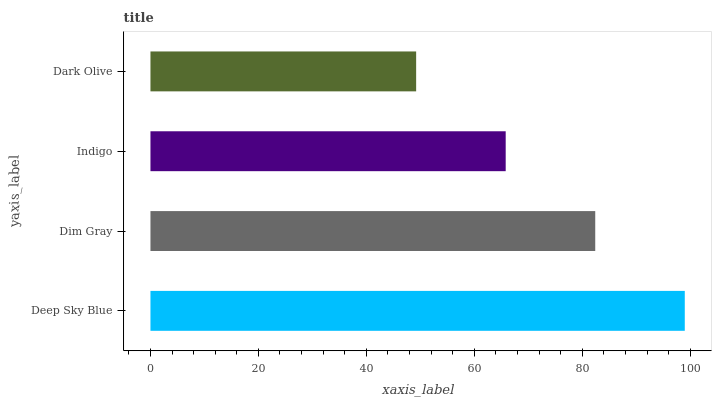Is Dark Olive the minimum?
Answer yes or no. Yes. Is Deep Sky Blue the maximum?
Answer yes or no. Yes. Is Dim Gray the minimum?
Answer yes or no. No. Is Dim Gray the maximum?
Answer yes or no. No. Is Deep Sky Blue greater than Dim Gray?
Answer yes or no. Yes. Is Dim Gray less than Deep Sky Blue?
Answer yes or no. Yes. Is Dim Gray greater than Deep Sky Blue?
Answer yes or no. No. Is Deep Sky Blue less than Dim Gray?
Answer yes or no. No. Is Dim Gray the high median?
Answer yes or no. Yes. Is Indigo the low median?
Answer yes or no. Yes. Is Indigo the high median?
Answer yes or no. No. Is Dark Olive the low median?
Answer yes or no. No. 